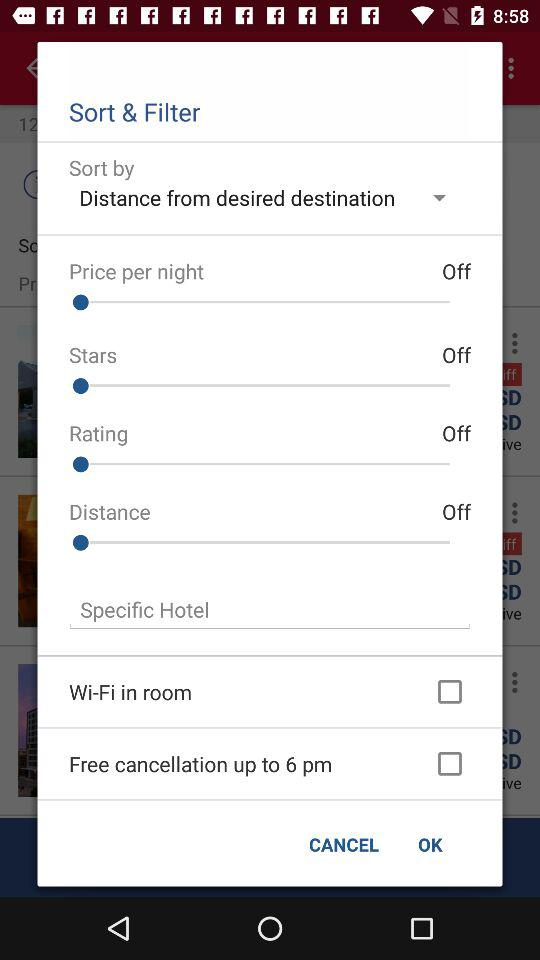How many of the filtering options have check boxes?
Answer the question using a single word or phrase. 2 